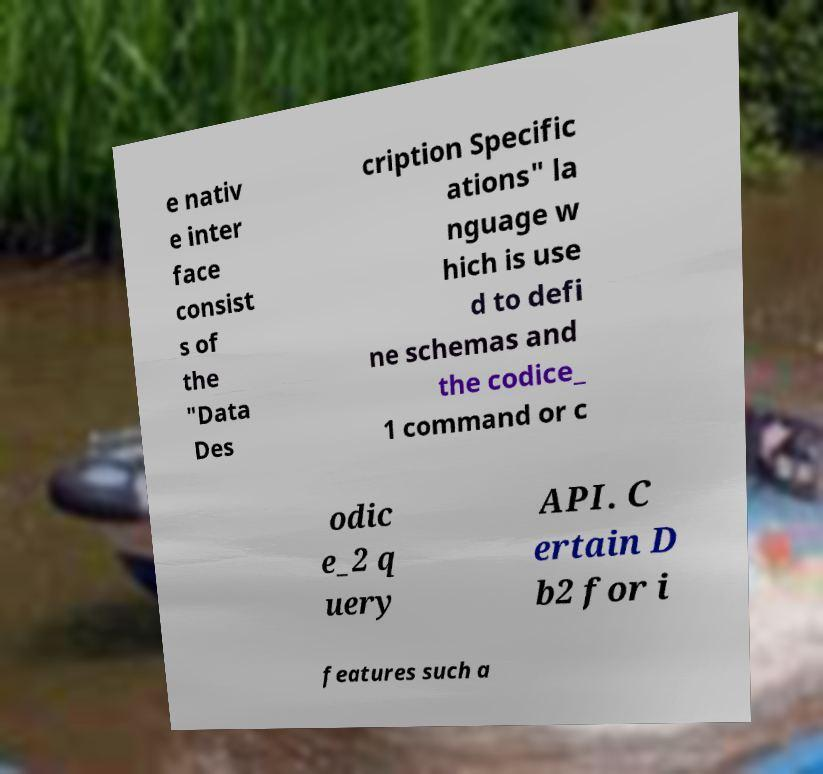Please read and relay the text visible in this image. What does it say? e nativ e inter face consist s of the "Data Des cription Specific ations" la nguage w hich is use d to defi ne schemas and the codice_ 1 command or c odic e_2 q uery API. C ertain D b2 for i features such a 